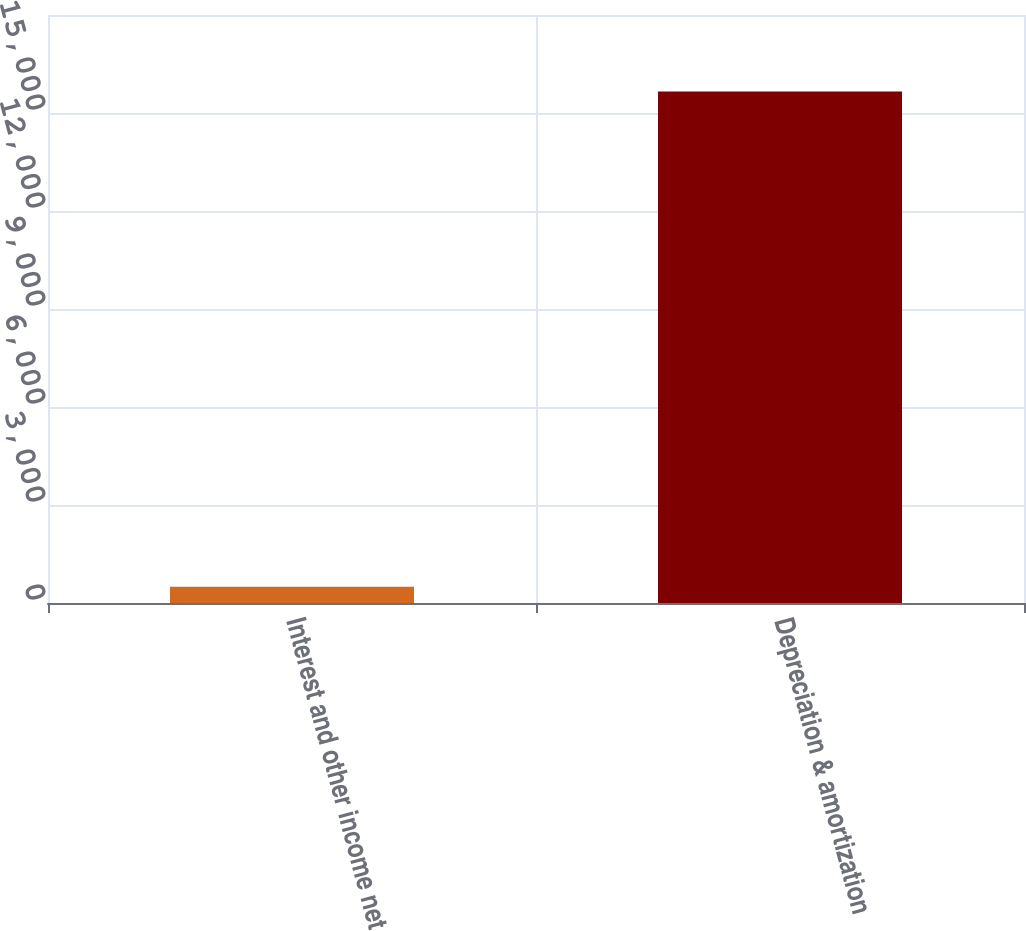Convert chart to OTSL. <chart><loc_0><loc_0><loc_500><loc_500><bar_chart><fcel>Interest and other income net<fcel>Depreciation & amortization<nl><fcel>494<fcel>15660<nl></chart> 